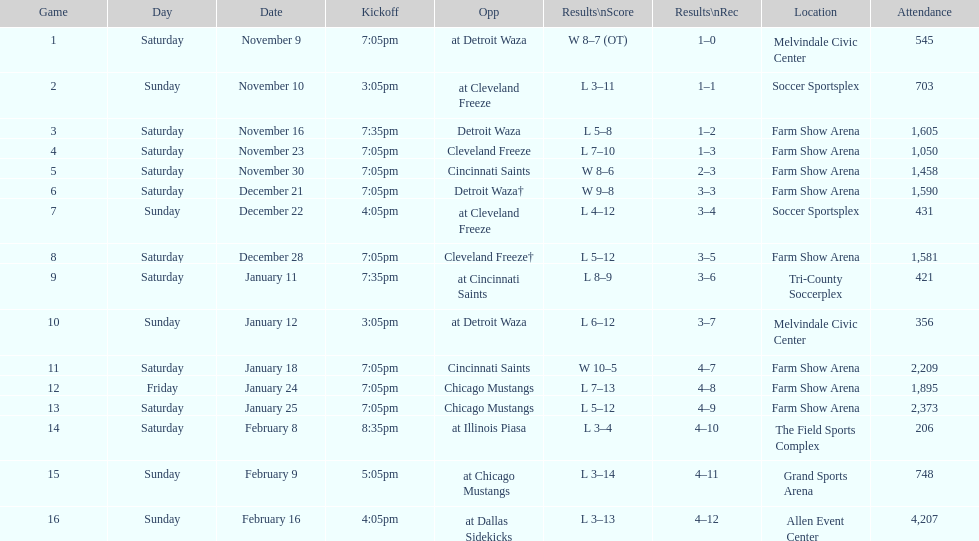In how many matches where the harrisburg heat scored 8 or more goals did they achieve victory? 4. 